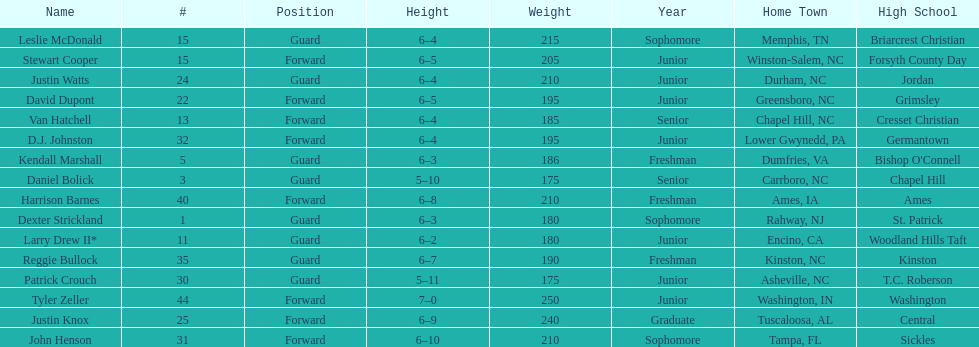Who was taller, justin knox or john henson? John Henson. 